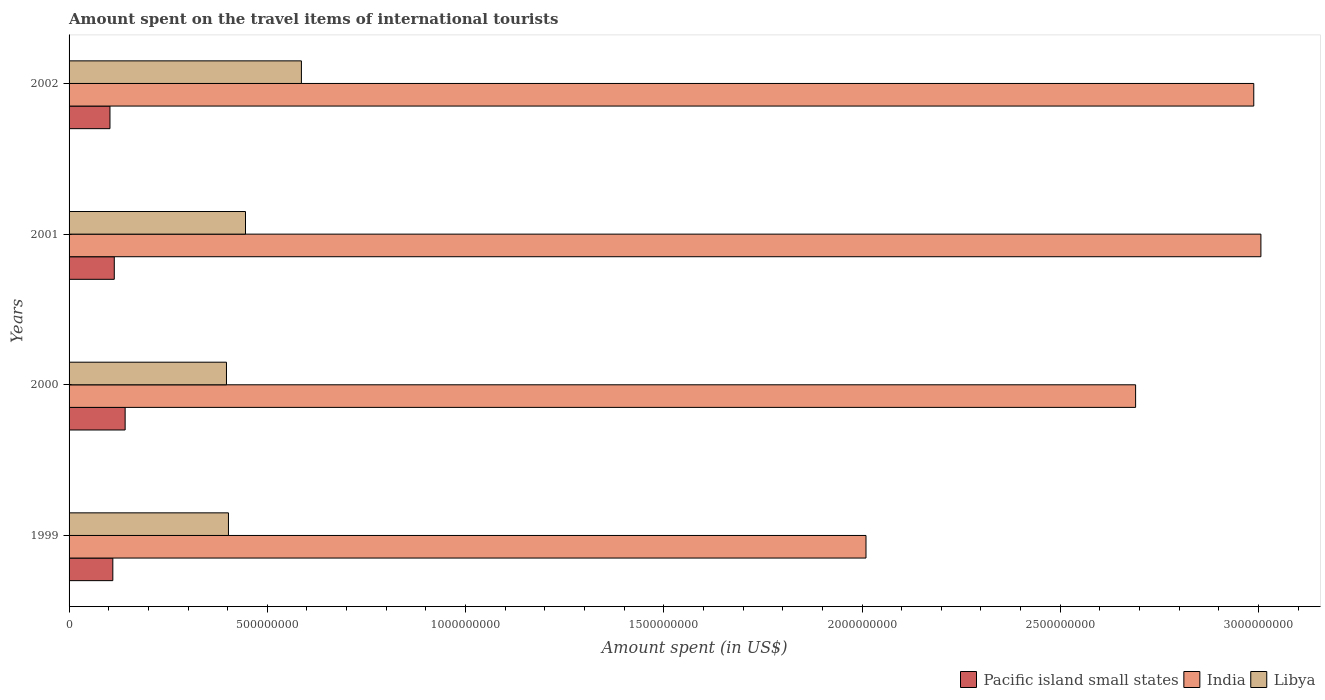How many different coloured bars are there?
Ensure brevity in your answer.  3. How many bars are there on the 2nd tick from the bottom?
Provide a succinct answer. 3. What is the label of the 3rd group of bars from the top?
Your answer should be very brief. 2000. In how many cases, is the number of bars for a given year not equal to the number of legend labels?
Offer a very short reply. 0. What is the amount spent on the travel items of international tourists in Pacific island small states in 2001?
Ensure brevity in your answer.  1.14e+08. Across all years, what is the maximum amount spent on the travel items of international tourists in Pacific island small states?
Offer a terse response. 1.41e+08. Across all years, what is the minimum amount spent on the travel items of international tourists in Pacific island small states?
Your response must be concise. 1.03e+08. In which year was the amount spent on the travel items of international tourists in Libya maximum?
Ensure brevity in your answer.  2002. In which year was the amount spent on the travel items of international tourists in Pacific island small states minimum?
Give a very brief answer. 2002. What is the total amount spent on the travel items of international tourists in Pacific island small states in the graph?
Ensure brevity in your answer.  4.69e+08. What is the difference between the amount spent on the travel items of international tourists in India in 1999 and that in 2001?
Offer a terse response. -9.96e+08. What is the difference between the amount spent on the travel items of international tourists in India in 1999 and the amount spent on the travel items of international tourists in Libya in 2002?
Offer a very short reply. 1.42e+09. What is the average amount spent on the travel items of international tourists in Pacific island small states per year?
Keep it short and to the point. 1.17e+08. In the year 2001, what is the difference between the amount spent on the travel items of international tourists in Libya and amount spent on the travel items of international tourists in Pacific island small states?
Provide a succinct answer. 3.31e+08. What is the ratio of the amount spent on the travel items of international tourists in India in 2000 to that in 2002?
Provide a succinct answer. 0.9. Is the difference between the amount spent on the travel items of international tourists in Libya in 2001 and 2002 greater than the difference between the amount spent on the travel items of international tourists in Pacific island small states in 2001 and 2002?
Your response must be concise. No. What is the difference between the highest and the second highest amount spent on the travel items of international tourists in Pacific island small states?
Provide a succinct answer. 2.74e+07. What is the difference between the highest and the lowest amount spent on the travel items of international tourists in Libya?
Provide a short and direct response. 1.89e+08. In how many years, is the amount spent on the travel items of international tourists in India greater than the average amount spent on the travel items of international tourists in India taken over all years?
Offer a very short reply. 3. Is the sum of the amount spent on the travel items of international tourists in India in 1999 and 2001 greater than the maximum amount spent on the travel items of international tourists in Pacific island small states across all years?
Offer a very short reply. Yes. What does the 3rd bar from the top in 2002 represents?
Offer a terse response. Pacific island small states. What does the 2nd bar from the bottom in 2002 represents?
Provide a succinct answer. India. What is the difference between two consecutive major ticks on the X-axis?
Give a very brief answer. 5.00e+08. Are the values on the major ticks of X-axis written in scientific E-notation?
Your answer should be compact. No. Does the graph contain grids?
Provide a short and direct response. No. Where does the legend appear in the graph?
Provide a succinct answer. Bottom right. How many legend labels are there?
Offer a terse response. 3. How are the legend labels stacked?
Ensure brevity in your answer.  Horizontal. What is the title of the graph?
Provide a short and direct response. Amount spent on the travel items of international tourists. Does "Uruguay" appear as one of the legend labels in the graph?
Offer a very short reply. No. What is the label or title of the X-axis?
Offer a terse response. Amount spent (in US$). What is the label or title of the Y-axis?
Provide a short and direct response. Years. What is the Amount spent (in US$) in Pacific island small states in 1999?
Your answer should be very brief. 1.10e+08. What is the Amount spent (in US$) in India in 1999?
Your answer should be very brief. 2.01e+09. What is the Amount spent (in US$) in Libya in 1999?
Keep it short and to the point. 4.02e+08. What is the Amount spent (in US$) in Pacific island small states in 2000?
Keep it short and to the point. 1.41e+08. What is the Amount spent (in US$) in India in 2000?
Provide a succinct answer. 2.69e+09. What is the Amount spent (in US$) of Libya in 2000?
Your answer should be compact. 3.97e+08. What is the Amount spent (in US$) in Pacific island small states in 2001?
Provide a short and direct response. 1.14e+08. What is the Amount spent (in US$) in India in 2001?
Provide a succinct answer. 3.01e+09. What is the Amount spent (in US$) of Libya in 2001?
Your response must be concise. 4.45e+08. What is the Amount spent (in US$) of Pacific island small states in 2002?
Your response must be concise. 1.03e+08. What is the Amount spent (in US$) in India in 2002?
Keep it short and to the point. 2.99e+09. What is the Amount spent (in US$) of Libya in 2002?
Provide a short and direct response. 5.86e+08. Across all years, what is the maximum Amount spent (in US$) of Pacific island small states?
Keep it short and to the point. 1.41e+08. Across all years, what is the maximum Amount spent (in US$) of India?
Offer a terse response. 3.01e+09. Across all years, what is the maximum Amount spent (in US$) in Libya?
Give a very brief answer. 5.86e+08. Across all years, what is the minimum Amount spent (in US$) of Pacific island small states?
Ensure brevity in your answer.  1.03e+08. Across all years, what is the minimum Amount spent (in US$) of India?
Your response must be concise. 2.01e+09. Across all years, what is the minimum Amount spent (in US$) in Libya?
Ensure brevity in your answer.  3.97e+08. What is the total Amount spent (in US$) of Pacific island small states in the graph?
Give a very brief answer. 4.69e+08. What is the total Amount spent (in US$) in India in the graph?
Your response must be concise. 1.07e+1. What is the total Amount spent (in US$) of Libya in the graph?
Ensure brevity in your answer.  1.83e+09. What is the difference between the Amount spent (in US$) of Pacific island small states in 1999 and that in 2000?
Make the answer very short. -3.11e+07. What is the difference between the Amount spent (in US$) in India in 1999 and that in 2000?
Offer a terse response. -6.80e+08. What is the difference between the Amount spent (in US$) in Pacific island small states in 1999 and that in 2001?
Your answer should be compact. -3.67e+06. What is the difference between the Amount spent (in US$) of India in 1999 and that in 2001?
Give a very brief answer. -9.96e+08. What is the difference between the Amount spent (in US$) in Libya in 1999 and that in 2001?
Your answer should be compact. -4.30e+07. What is the difference between the Amount spent (in US$) of Pacific island small states in 1999 and that in 2002?
Ensure brevity in your answer.  7.20e+06. What is the difference between the Amount spent (in US$) of India in 1999 and that in 2002?
Your answer should be compact. -9.78e+08. What is the difference between the Amount spent (in US$) of Libya in 1999 and that in 2002?
Make the answer very short. -1.84e+08. What is the difference between the Amount spent (in US$) in Pacific island small states in 2000 and that in 2001?
Provide a succinct answer. 2.74e+07. What is the difference between the Amount spent (in US$) of India in 2000 and that in 2001?
Offer a very short reply. -3.16e+08. What is the difference between the Amount spent (in US$) in Libya in 2000 and that in 2001?
Your answer should be very brief. -4.80e+07. What is the difference between the Amount spent (in US$) of Pacific island small states in 2000 and that in 2002?
Offer a terse response. 3.83e+07. What is the difference between the Amount spent (in US$) of India in 2000 and that in 2002?
Your answer should be very brief. -2.98e+08. What is the difference between the Amount spent (in US$) of Libya in 2000 and that in 2002?
Your answer should be compact. -1.89e+08. What is the difference between the Amount spent (in US$) of Pacific island small states in 2001 and that in 2002?
Offer a very short reply. 1.09e+07. What is the difference between the Amount spent (in US$) in India in 2001 and that in 2002?
Make the answer very short. 1.80e+07. What is the difference between the Amount spent (in US$) in Libya in 2001 and that in 2002?
Your answer should be very brief. -1.41e+08. What is the difference between the Amount spent (in US$) of Pacific island small states in 1999 and the Amount spent (in US$) of India in 2000?
Offer a terse response. -2.58e+09. What is the difference between the Amount spent (in US$) in Pacific island small states in 1999 and the Amount spent (in US$) in Libya in 2000?
Your response must be concise. -2.87e+08. What is the difference between the Amount spent (in US$) of India in 1999 and the Amount spent (in US$) of Libya in 2000?
Your response must be concise. 1.61e+09. What is the difference between the Amount spent (in US$) in Pacific island small states in 1999 and the Amount spent (in US$) in India in 2001?
Your answer should be compact. -2.90e+09. What is the difference between the Amount spent (in US$) in Pacific island small states in 1999 and the Amount spent (in US$) in Libya in 2001?
Your answer should be compact. -3.35e+08. What is the difference between the Amount spent (in US$) of India in 1999 and the Amount spent (in US$) of Libya in 2001?
Your answer should be compact. 1.56e+09. What is the difference between the Amount spent (in US$) in Pacific island small states in 1999 and the Amount spent (in US$) in India in 2002?
Your answer should be compact. -2.88e+09. What is the difference between the Amount spent (in US$) of Pacific island small states in 1999 and the Amount spent (in US$) of Libya in 2002?
Provide a succinct answer. -4.76e+08. What is the difference between the Amount spent (in US$) in India in 1999 and the Amount spent (in US$) in Libya in 2002?
Your response must be concise. 1.42e+09. What is the difference between the Amount spent (in US$) of Pacific island small states in 2000 and the Amount spent (in US$) of India in 2001?
Your answer should be very brief. -2.86e+09. What is the difference between the Amount spent (in US$) of Pacific island small states in 2000 and the Amount spent (in US$) of Libya in 2001?
Offer a very short reply. -3.04e+08. What is the difference between the Amount spent (in US$) in India in 2000 and the Amount spent (in US$) in Libya in 2001?
Provide a short and direct response. 2.24e+09. What is the difference between the Amount spent (in US$) in Pacific island small states in 2000 and the Amount spent (in US$) in India in 2002?
Provide a short and direct response. -2.85e+09. What is the difference between the Amount spent (in US$) in Pacific island small states in 2000 and the Amount spent (in US$) in Libya in 2002?
Your answer should be compact. -4.45e+08. What is the difference between the Amount spent (in US$) in India in 2000 and the Amount spent (in US$) in Libya in 2002?
Make the answer very short. 2.10e+09. What is the difference between the Amount spent (in US$) of Pacific island small states in 2001 and the Amount spent (in US$) of India in 2002?
Your answer should be compact. -2.87e+09. What is the difference between the Amount spent (in US$) in Pacific island small states in 2001 and the Amount spent (in US$) in Libya in 2002?
Offer a very short reply. -4.72e+08. What is the difference between the Amount spent (in US$) of India in 2001 and the Amount spent (in US$) of Libya in 2002?
Make the answer very short. 2.42e+09. What is the average Amount spent (in US$) of Pacific island small states per year?
Keep it short and to the point. 1.17e+08. What is the average Amount spent (in US$) of India per year?
Your response must be concise. 2.67e+09. What is the average Amount spent (in US$) of Libya per year?
Give a very brief answer. 4.58e+08. In the year 1999, what is the difference between the Amount spent (in US$) of Pacific island small states and Amount spent (in US$) of India?
Offer a terse response. -1.90e+09. In the year 1999, what is the difference between the Amount spent (in US$) of Pacific island small states and Amount spent (in US$) of Libya?
Offer a very short reply. -2.92e+08. In the year 1999, what is the difference between the Amount spent (in US$) of India and Amount spent (in US$) of Libya?
Keep it short and to the point. 1.61e+09. In the year 2000, what is the difference between the Amount spent (in US$) in Pacific island small states and Amount spent (in US$) in India?
Offer a terse response. -2.55e+09. In the year 2000, what is the difference between the Amount spent (in US$) of Pacific island small states and Amount spent (in US$) of Libya?
Make the answer very short. -2.56e+08. In the year 2000, what is the difference between the Amount spent (in US$) of India and Amount spent (in US$) of Libya?
Provide a short and direct response. 2.29e+09. In the year 2001, what is the difference between the Amount spent (in US$) of Pacific island small states and Amount spent (in US$) of India?
Your answer should be compact. -2.89e+09. In the year 2001, what is the difference between the Amount spent (in US$) of Pacific island small states and Amount spent (in US$) of Libya?
Your response must be concise. -3.31e+08. In the year 2001, what is the difference between the Amount spent (in US$) in India and Amount spent (in US$) in Libya?
Offer a terse response. 2.56e+09. In the year 2002, what is the difference between the Amount spent (in US$) of Pacific island small states and Amount spent (in US$) of India?
Offer a very short reply. -2.88e+09. In the year 2002, what is the difference between the Amount spent (in US$) of Pacific island small states and Amount spent (in US$) of Libya?
Provide a short and direct response. -4.83e+08. In the year 2002, what is the difference between the Amount spent (in US$) of India and Amount spent (in US$) of Libya?
Provide a succinct answer. 2.40e+09. What is the ratio of the Amount spent (in US$) of Pacific island small states in 1999 to that in 2000?
Your response must be concise. 0.78. What is the ratio of the Amount spent (in US$) of India in 1999 to that in 2000?
Provide a succinct answer. 0.75. What is the ratio of the Amount spent (in US$) in Libya in 1999 to that in 2000?
Offer a very short reply. 1.01. What is the ratio of the Amount spent (in US$) in Pacific island small states in 1999 to that in 2001?
Ensure brevity in your answer.  0.97. What is the ratio of the Amount spent (in US$) of India in 1999 to that in 2001?
Keep it short and to the point. 0.67. What is the ratio of the Amount spent (in US$) in Libya in 1999 to that in 2001?
Make the answer very short. 0.9. What is the ratio of the Amount spent (in US$) in Pacific island small states in 1999 to that in 2002?
Keep it short and to the point. 1.07. What is the ratio of the Amount spent (in US$) in India in 1999 to that in 2002?
Make the answer very short. 0.67. What is the ratio of the Amount spent (in US$) of Libya in 1999 to that in 2002?
Your answer should be compact. 0.69. What is the ratio of the Amount spent (in US$) of Pacific island small states in 2000 to that in 2001?
Your response must be concise. 1.24. What is the ratio of the Amount spent (in US$) of India in 2000 to that in 2001?
Offer a very short reply. 0.89. What is the ratio of the Amount spent (in US$) in Libya in 2000 to that in 2001?
Give a very brief answer. 0.89. What is the ratio of the Amount spent (in US$) in Pacific island small states in 2000 to that in 2002?
Your answer should be very brief. 1.37. What is the ratio of the Amount spent (in US$) in India in 2000 to that in 2002?
Offer a very short reply. 0.9. What is the ratio of the Amount spent (in US$) of Libya in 2000 to that in 2002?
Offer a very short reply. 0.68. What is the ratio of the Amount spent (in US$) in Pacific island small states in 2001 to that in 2002?
Keep it short and to the point. 1.11. What is the ratio of the Amount spent (in US$) of India in 2001 to that in 2002?
Make the answer very short. 1.01. What is the ratio of the Amount spent (in US$) of Libya in 2001 to that in 2002?
Give a very brief answer. 0.76. What is the difference between the highest and the second highest Amount spent (in US$) in Pacific island small states?
Your answer should be compact. 2.74e+07. What is the difference between the highest and the second highest Amount spent (in US$) in India?
Your answer should be very brief. 1.80e+07. What is the difference between the highest and the second highest Amount spent (in US$) in Libya?
Offer a very short reply. 1.41e+08. What is the difference between the highest and the lowest Amount spent (in US$) in Pacific island small states?
Your response must be concise. 3.83e+07. What is the difference between the highest and the lowest Amount spent (in US$) in India?
Provide a short and direct response. 9.96e+08. What is the difference between the highest and the lowest Amount spent (in US$) of Libya?
Provide a short and direct response. 1.89e+08. 